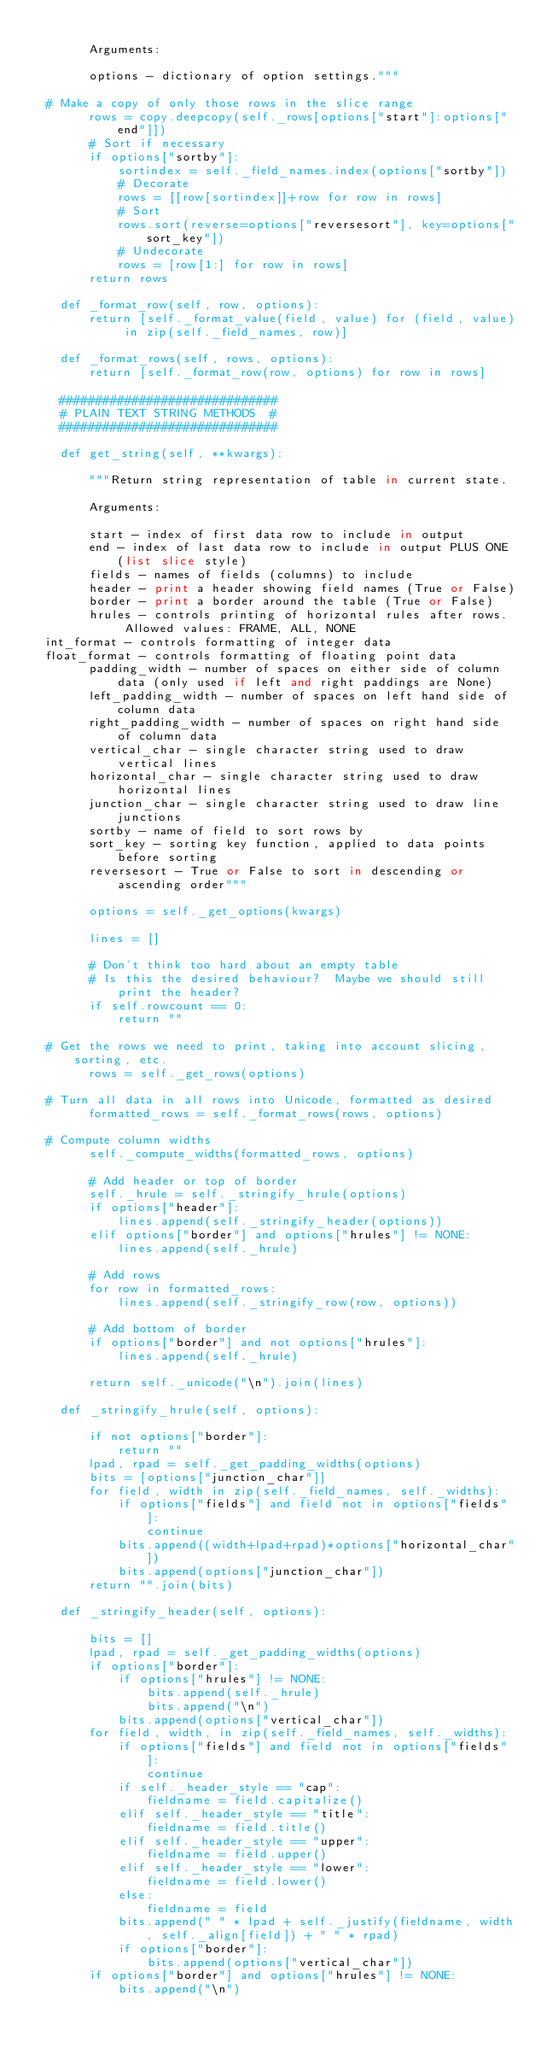<code> <loc_0><loc_0><loc_500><loc_500><_Python_>
        Arguments:

        options - dictionary of option settings."""
       
	# Make a copy of only those rows in the slice range 
        rows = copy.deepcopy(self._rows[options["start"]:options["end"]])
        # Sort if necessary
        if options["sortby"]:
            sortindex = self._field_names.index(options["sortby"])
            # Decorate
            rows = [[row[sortindex]]+row for row in rows]
            # Sort
            rows.sort(reverse=options["reversesort"], key=options["sort_key"])
            # Undecorate
            rows = [row[1:] for row in rows]
        return rows
        
    def _format_row(self, row, options):
        return [self._format_value(field, value) for (field, value) in zip(self._field_names, row)]

    def _format_rows(self, rows, options):
        return [self._format_row(row, options) for row in rows]
 
    ##############################
    # PLAIN TEXT STRING METHODS  #
    ##############################

    def get_string(self, **kwargs):

        """Return string representation of table in current state.

        Arguments:

        start - index of first data row to include in output
        end - index of last data row to include in output PLUS ONE (list slice style)
        fields - names of fields (columns) to include
        header - print a header showing field names (True or False)
        border - print a border around the table (True or False)
        hrules - controls printing of horizontal rules after rows.  Allowed values: FRAME, ALL, NONE
	int_format - controls formatting of integer data
	float_format - controls formatting of floating point data
        padding_width - number of spaces on either side of column data (only used if left and right paddings are None)
        left_padding_width - number of spaces on left hand side of column data
        right_padding_width - number of spaces on right hand side of column data
        vertical_char - single character string used to draw vertical lines
        horizontal_char - single character string used to draw horizontal lines
        junction_char - single character string used to draw line junctions
        sortby - name of field to sort rows by
        sort_key - sorting key function, applied to data points before sorting
        reversesort - True or False to sort in descending or ascending order"""

        options = self._get_options(kwargs)

        lines = []

        # Don't think too hard about an empty table
        # Is this the desired behaviour?  Maybe we should still print the header?
        if self.rowcount == 0:
            return ""

	# Get the rows we need to print, taking into account slicing, sorting, etc.
        rows = self._get_rows(options)

	# Turn all data in all rows into Unicode, formatted as desired
        formatted_rows = self._format_rows(rows, options)

	# Compute column widths
        self._compute_widths(formatted_rows, options)

        # Add header or top of border
        self._hrule = self._stringify_hrule(options)
        if options["header"]:
            lines.append(self._stringify_header(options))
        elif options["border"] and options["hrules"] != NONE:
            lines.append(self._hrule)

        # Add rows
        for row in formatted_rows:
            lines.append(self._stringify_row(row, options))

        # Add bottom of border
        if options["border"] and not options["hrules"]:
            lines.append(self._hrule)
        
        return self._unicode("\n").join(lines)

    def _stringify_hrule(self, options):

        if not options["border"]:
            return ""
        lpad, rpad = self._get_padding_widths(options)
        bits = [options["junction_char"]]
        for field, width in zip(self._field_names, self._widths):
            if options["fields"] and field not in options["fields"]:
                continue
            bits.append((width+lpad+rpad)*options["horizontal_char"])
            bits.append(options["junction_char"])
        return "".join(bits)

    def _stringify_header(self, options):

        bits = []
        lpad, rpad = self._get_padding_widths(options)
        if options["border"]:
            if options["hrules"] != NONE:
                bits.append(self._hrule)
                bits.append("\n")
            bits.append(options["vertical_char"])
        for field, width, in zip(self._field_names, self._widths):
            if options["fields"] and field not in options["fields"]:
                continue
            if self._header_style == "cap":
                fieldname = field.capitalize()
            elif self._header_style == "title":
                fieldname = field.title()
            elif self._header_style == "upper":
                fieldname = field.upper()
            elif self._header_style == "lower":
                fieldname = field.lower()
            else:
                fieldname = field
            bits.append(" " * lpad + self._justify(fieldname, width, self._align[field]) + " " * rpad)
            if options["border"]:
                bits.append(options["vertical_char"])
        if options["border"] and options["hrules"] != NONE:
            bits.append("\n")</code> 